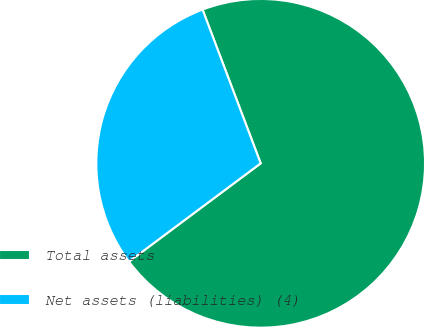Convert chart to OTSL. <chart><loc_0><loc_0><loc_500><loc_500><pie_chart><fcel>Total assets<fcel>Net assets (liabilities) (4)<nl><fcel>70.55%<fcel>29.45%<nl></chart> 